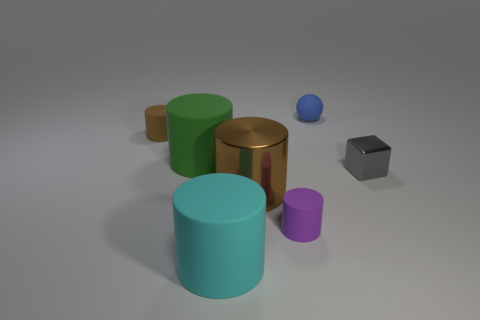Subtract all brown shiny cylinders. How many cylinders are left? 4 Subtract all gray blocks. How many brown cylinders are left? 2 Add 3 cyan objects. How many objects exist? 10 Subtract 1 cylinders. How many cylinders are left? 4 Subtract all green cylinders. How many cylinders are left? 4 Subtract all blocks. How many objects are left? 6 Subtract all gray cylinders. Subtract all yellow balls. How many cylinders are left? 5 Add 5 big purple metal spheres. How many big purple metal spheres exist? 5 Subtract 0 red cylinders. How many objects are left? 7 Subtract all large green matte cylinders. Subtract all cyan things. How many objects are left? 5 